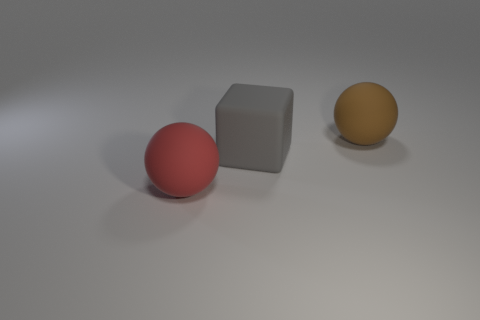Add 2 big red matte things. How many objects exist? 5 Subtract all cubes. How many objects are left? 2 Add 3 rubber things. How many rubber things are left? 6 Add 2 gray shiny cylinders. How many gray shiny cylinders exist? 2 Subtract 0 gray balls. How many objects are left? 3 Subtract all large metallic cylinders. Subtract all large brown things. How many objects are left? 2 